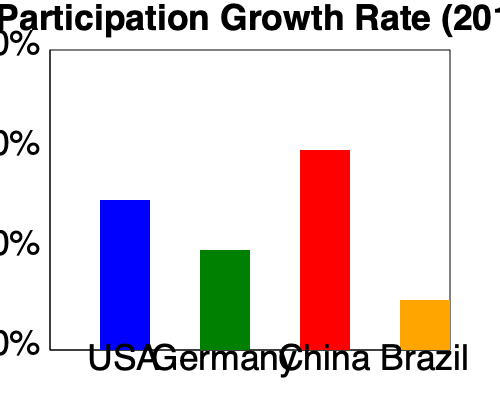Based on the bar graph showing cricket participation growth rates in non-traditional cricket nations from 2015 to 2020, which country has experienced the highest percentage increase, and what is the approximate difference between the highest and lowest growth rates? To answer this question, we need to analyze the bar graph and follow these steps:

1. Identify the countries represented: USA, Germany, China, and Brazil.

2. Compare the heights of the bars to determine the highest growth rate:
   - USA: approximately 75%
   - Germany: approximately 50%
   - China: approximately 100%
   - Brazil: approximately 25%

3. The country with the highest growth rate is China at 100%.

4. To find the difference between the highest and lowest growth rates:
   - Highest growth rate: China at 100%
   - Lowest growth rate: Brazil at 25%
   - Difference: $100% - 25% = 75%$

Therefore, China has experienced the highest percentage increase in cricket participation, and the approximate difference between the highest (China) and lowest (Brazil) growth rates is 75%.
Answer: China; 75% 